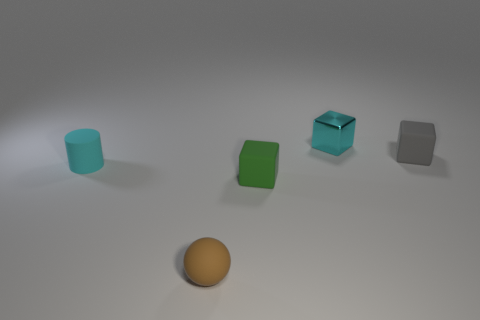Add 3 tiny red shiny spheres. How many objects exist? 8 Subtract all balls. How many objects are left? 4 Subtract 1 brown spheres. How many objects are left? 4 Subtract all tiny cyan rubber things. Subtract all small brown objects. How many objects are left? 3 Add 1 small cyan cubes. How many small cyan cubes are left? 2 Add 2 tiny brown metallic things. How many tiny brown metallic things exist? 2 